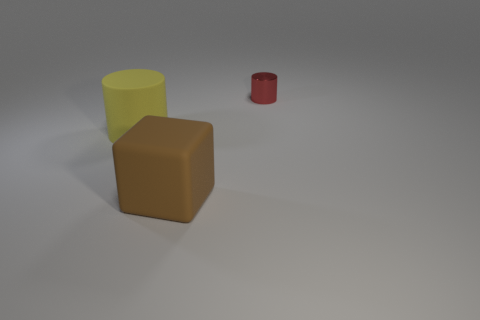There is a large object to the left of the brown matte cube; what is its shape?
Your response must be concise. Cylinder. Is the material of the big brown thing the same as the red object that is on the right side of the yellow cylinder?
Your answer should be compact. No. Are there any small brown spheres?
Provide a short and direct response. No. Are there any big cylinders on the left side of the big object that is behind the big rubber thing that is on the right side of the big yellow object?
Provide a succinct answer. No. How many big objects are either gray shiny cubes or cylinders?
Offer a very short reply. 1. There is a matte object that is the same size as the yellow matte cylinder; what color is it?
Keep it short and to the point. Brown. There is a metallic cylinder; what number of red metallic things are to the right of it?
Keep it short and to the point. 0. Are there any small cylinders that have the same material as the large brown thing?
Your response must be concise. No. There is a big object behind the big matte cube; what color is it?
Your answer should be compact. Yellow. Are there an equal number of brown cubes behind the brown block and large rubber cylinders behind the tiny metallic object?
Provide a short and direct response. Yes. 